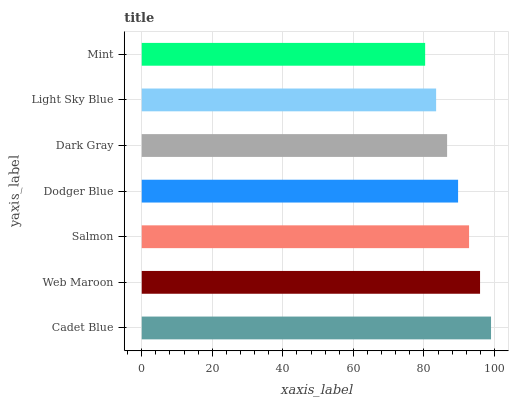Is Mint the minimum?
Answer yes or no. Yes. Is Cadet Blue the maximum?
Answer yes or no. Yes. Is Web Maroon the minimum?
Answer yes or no. No. Is Web Maroon the maximum?
Answer yes or no. No. Is Cadet Blue greater than Web Maroon?
Answer yes or no. Yes. Is Web Maroon less than Cadet Blue?
Answer yes or no. Yes. Is Web Maroon greater than Cadet Blue?
Answer yes or no. No. Is Cadet Blue less than Web Maroon?
Answer yes or no. No. Is Dodger Blue the high median?
Answer yes or no. Yes. Is Dodger Blue the low median?
Answer yes or no. Yes. Is Mint the high median?
Answer yes or no. No. Is Web Maroon the low median?
Answer yes or no. No. 